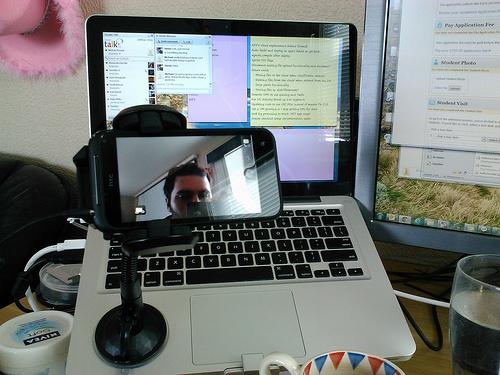Please provide a brief summary of the objects found in this image. The image contains a laptop, a mobile phone mounted to the computer, a keyboard, a touchpad, a colorful mug, a glass of water, a container of nivea cream, a pink hat on the wall, and additional details of each item. Explain the arrangement of the items on the desk in the image. On the desk, there is a laptop with a mobile phone mounted to it, a portion of a colorful mug, a small glass of water, a container of nivea cream, and a cell phone stand. The desk also has a light brown color. Can you describe the mobile phone and its position in relation to the laptop computer? The mobile phone is black, mounted horizontally to the computer on a stand, with a man's face visible on its screen. It is positioned to the right and slightly above the laptop's keyboard. How is the smartphone in the image positioned, and is there any visible information on the phone's screen? The smartphone is positioned horizontally and has a visible man's face on the screen, possibly from a video call. Based on the objects and their arrangement in the image, what conclusions can be drawn about the scene's purpose or activity? The scene could belong to a workspace or home office where someone is using a laptop and a smartphone simultaneously, possibly for multitasking or attending a virtual meeting. What are the visible software programs running on the laptop? Google Talk contact list, Windows Sticky Note list, and program icons in the Windows taskbar. Identify the color of the wall and the presence of any decorations or items on it. The wall is white, and there is a pink hat hanging on it. What is the primary electronic device shown in this image? A laptop computer with its screen visible along with additional electronic devices like a mobile phone and a large monitor. What personal care items are visible in the image? A container of nivea cream and a container of lotion. Describe the drinkware items found in the image. A partial view of a red, white, and blue mug, and an almost full glass of still water. Describe the appearance of the mobile phone. The smartphone is black and horizontally placed. Is there any partially visible object next to the computer? If yes, describe it briefly. Yes, a portion of a colorful mug and a glass of water. What does the man's face appear on? The screen on a mobile phone Describe the charging cord connected to the laptop. The charging cord is white. Can you see a purple hat hanging on the wall with yellow polka dots? There is a pink hat on the wall, but it's not purple and there are no mentions of yellow polka dots on it. Is the laptop computer green and placed on the left side of the desk? The laptop computer is actually black and gray, not green, and it's not specified if it's on the left side of the desk. What type of computer is present in the image? A black and grey laptop computer Where is the container of hand cream located? To the left What type of container is adjacent to the keyboard? A container of nivea cream What is the phone mounted on?  A stand What part of the mobile phone has a man's face on it? The screen Is there a container of chocolate ice cream next to the handcream? The image shows a container of Nivea cream, not chocolate ice cream, next to the handcream. Can you see a blue computer monitor with yellow borders? The computer monitor in the image is black, not blue, and there's no mention of yellow borders. Identify the device that uses the touchpad. The laptop computer List the items visible on the desk. Laptop, mobile phone, Nivea cream container, colorful mug, glass of water, touchpad, keyboard, phone stand, monitor. What is the main object on the table? A laptop computer What is the color and texture of the wall? The wall has a cream color and has texture. What are the colors of the coffee cup? Red, white, and blue What are the items on the wall?  A pink hat and a white plaster wall with texture. Is the smartphone attached to a purple stand? The image only mentions the phone being attached to a stand, but it does not specify the stand to be purple. Is there a tall glass of orange juice next to the computer? The image contains a glass of still water, not a tall glass of orange juice next to the computer. What programs are open on the laptop screen? Google talk, contact list, and windows sticky note list. Choose the correct object attached to the computer: a) mobile phone, b) tablet c) mouse. a) mobile phone What is the color of the hat on the wall? Pink 